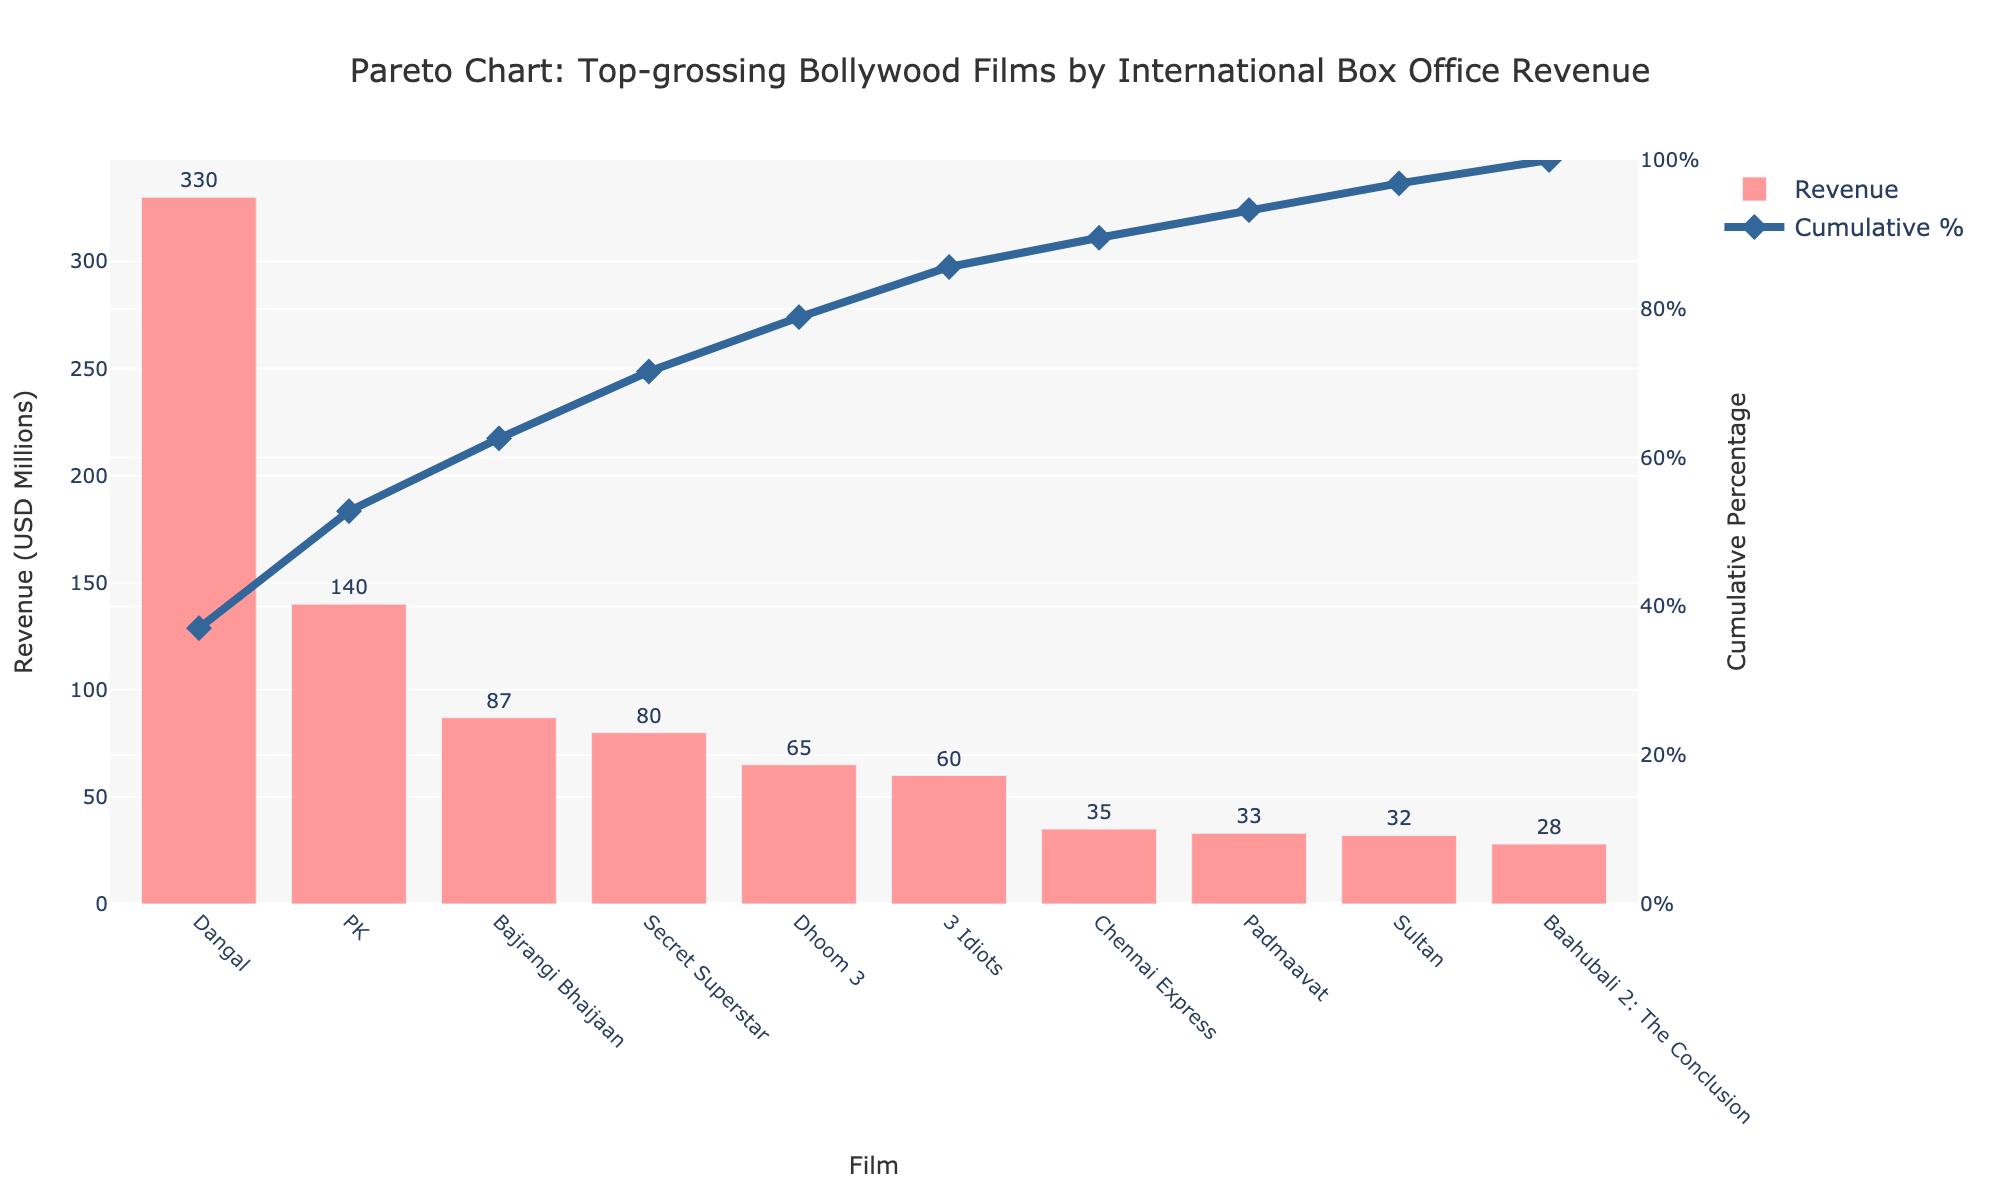Which film has the highest international box office revenue? The bar chart shows the revenue values for each film. The highest value belongs to the film "Dangal" with 330 USD Millions.
Answer: Dangal How many films have an international box office revenue above 50 USD Millions? By looking at the heights of the bars, we count the films with revenues higher than 50 USD Millions: Dangal, PK, Bajrangi Bhaijaan, Secret Superstar, Dhoom 3, and 3 Idiots. That's a total of 6 films.
Answer: 6 What is the combined international box office revenue of the bottom three films in the list? The revenues of the bottom three films are Chennai Express (35 USD Millions), Padmaavat (33 USD Millions), and Sultan (32 USD Millions). Summing these values gives 35 + 33 + 32 = 100 USD Millions.
Answer: 100 What is the cumulative percentage contribution of the top two films? The cumulative percentage contribution found on the graph line for the top two films (Dangal and PK) is approximately 70% (Dangal at around 53% and PK adding the rest up to 70%).
Answer: 70% Which film shows a cumulative percentage closest to 100%? The scatter plot line for cumulative percentage reaches near 100% at Baahubali 2: The Conclusion, which is the last film plotted. The cumulative percentage for it is closest to 100%.
Answer: Baahubali 2: The Conclusion What is the difference in international box office revenue between the film with the highest and the film with the lowest revenue? The highest revenue film is "Dangal" (330 USD Millions) and the lowest is "Baahubali 2: The Conclusion" (28 USD Millions). The difference is 330 - 28 = 302 USD Millions.
Answer: 302 Which film has the third highest international box office revenue? By observing the heights of the bars, the third tallest bar represents "Bajrangi Bhaijaan" with an international box office revenue of 87 USD Millions.
Answer: Bajrangi Bhaijaan How many films collectively account for more than 80% of the total international box office revenue? Observing the cumulative percentage line, the contribution exceeds 80% at "Secret Superstar," which is the fourth film in the list.
Answer: 4 